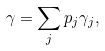Convert formula to latex. <formula><loc_0><loc_0><loc_500><loc_500>\gamma = \sum _ { j } p _ { j } \gamma _ { j } ,</formula> 